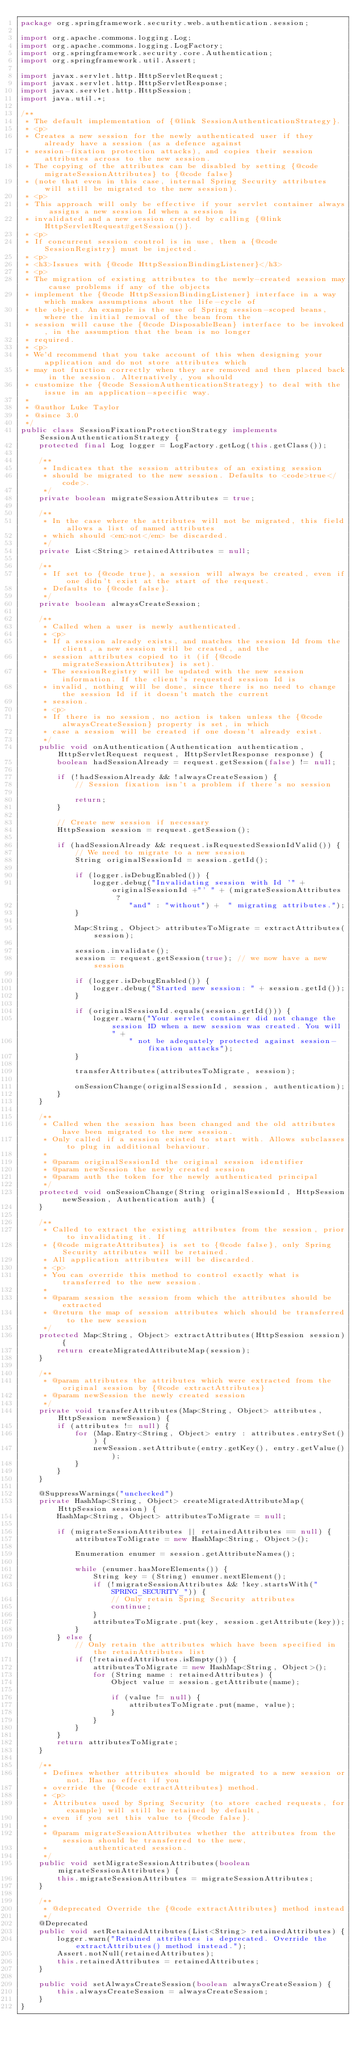Convert code to text. <code><loc_0><loc_0><loc_500><loc_500><_Java_>package org.springframework.security.web.authentication.session;

import org.apache.commons.logging.Log;
import org.apache.commons.logging.LogFactory;
import org.springframework.security.core.Authentication;
import org.springframework.util.Assert;

import javax.servlet.http.HttpServletRequest;
import javax.servlet.http.HttpServletResponse;
import javax.servlet.http.HttpSession;
import java.util.*;

/**
 * The default implementation of {@link SessionAuthenticationStrategy}.
 * <p>
 * Creates a new session for the newly authenticated user if they already have a session (as a defence against
 * session-fixation protection attacks), and copies their session attributes across to the new session.
 * The copying of the attributes can be disabled by setting {@code migrateSessionAttributes} to {@code false}
 * (note that even in this case, internal Spring Security attributes will still be migrated to the new session).
 * <p>
 * This approach will only be effective if your servlet container always assigns a new session Id when a session is
 * invalidated and a new session created by calling {@link HttpServletRequest#getSession()}.
 * <p>
 * If concurrent session control is in use, then a {@code SessionRegistry} must be injected.
 * <p>
 * <h3>Issues with {@code HttpSessionBindingListener}</h3>
 * <p>
 * The migration of existing attributes to the newly-created session may cause problems if any of the objects
 * implement the {@code HttpSessionBindingListener} interface in a way which makes assumptions about the life-cycle of
 * the object. An example is the use of Spring session-scoped beans, where the initial removal of the bean from the
 * session will cause the {@code DisposableBean} interface to be invoked, in the assumption that the bean is no longer
 * required.
 * <p>
 * We'd recommend that you take account of this when designing your application and do not store attributes which
 * may not function correctly when they are removed and then placed back in the session. Alternatively, you should
 * customize the {@code SessionAuthenticationStrategy} to deal with the issue in an application-specific way.
 *
 * @author Luke Taylor
 * @since 3.0
 */
public class SessionFixationProtectionStrategy implements SessionAuthenticationStrategy {
    protected final Log logger = LogFactory.getLog(this.getClass());

    /**
     * Indicates that the session attributes of an existing session
     * should be migrated to the new session. Defaults to <code>true</code>.
     */
    private boolean migrateSessionAttributes = true;

    /**
     * In the case where the attributes will not be migrated, this field allows a list of named attributes
     * which should <em>not</em> be discarded.
     */
    private List<String> retainedAttributes = null;

    /**
     * If set to {@code true}, a session will always be created, even if one didn't exist at the start of the request.
     * Defaults to {@code false}.
     */
    private boolean alwaysCreateSession;

    /**
     * Called when a user is newly authenticated.
     * <p>
     * If a session already exists, and matches the session Id from the client, a new session will be created, and the
     * session attributes copied to it (if {@code migrateSessionAttributes} is set).
     * The sessionRegistry will be updated with the new session information. If the client's requested session Id is
     * invalid, nothing will be done, since there is no need to change the session Id if it doesn't match the current
     * session.
     * <p>
     * If there is no session, no action is taken unless the {@code alwaysCreateSession} property is set, in which
     * case a session will be created if one doesn't already exist.
     */
    public void onAuthentication(Authentication authentication, HttpServletRequest request, HttpServletResponse response) {
        boolean hadSessionAlready = request.getSession(false) != null;

        if (!hadSessionAlready && !alwaysCreateSession) {
            // Session fixation isn't a problem if there's no session

            return;
        }

        // Create new session if necessary
        HttpSession session = request.getSession();

        if (hadSessionAlready && request.isRequestedSessionIdValid()) {
            // We need to migrate to a new session
            String originalSessionId = session.getId();

            if (logger.isDebugEnabled()) {
                logger.debug("Invalidating session with Id '" + originalSessionId +"' " + (migrateSessionAttributes ?
                        "and" : "without") +  " migrating attributes.");
            }

            Map<String, Object> attributesToMigrate = extractAttributes(session);

            session.invalidate();
            session = request.getSession(true); // we now have a new session

            if (logger.isDebugEnabled()) {
                logger.debug("Started new session: " + session.getId());
            }

            if (originalSessionId.equals(session.getId())) {
                logger.warn("Your servlet container did not change the session ID when a new session was created. You will" +
                        " not be adequately protected against session-fixation attacks");
            }

            transferAttributes(attributesToMigrate, session);

            onSessionChange(originalSessionId, session, authentication);
        }
    }

    /**
     * Called when the session has been changed and the old attributes have been migrated to the new session.
     * Only called if a session existed to start with. Allows subclasses to plug in additional behaviour.
     *
     * @param originalSessionId the original session identifier
     * @param newSession the newly created session
     * @param auth the token for the newly authenticated principal
     */
    protected void onSessionChange(String originalSessionId, HttpSession newSession, Authentication auth) {
    }

    /**
     * Called to extract the existing attributes from the session, prior to invalidating it. If
     * {@code migrateAttributes} is set to {@code false}, only Spring Security attributes will be retained.
     * All application attributes will be discarded.
     * <p>
     * You can override this method to control exactly what is transferred to the new session.
     *
     * @param session the session from which the attributes should be extracted
     * @return the map of session attributes which should be transferred to the new session
     */
    protected Map<String, Object> extractAttributes(HttpSession session) {
        return createMigratedAttributeMap(session);
    }

    /**
     * @param attributes the attributes which were extracted from the original session by {@code extractAttributes}
     * @param newSession the newly created session
     */
    private void transferAttributes(Map<String, Object> attributes, HttpSession newSession) {
        if (attributes != null) {
            for (Map.Entry<String, Object> entry : attributes.entrySet()) {
                newSession.setAttribute(entry.getKey(), entry.getValue());
            }
        }
    }

    @SuppressWarnings("unchecked")
    private HashMap<String, Object> createMigratedAttributeMap(HttpSession session) {
        HashMap<String, Object> attributesToMigrate = null;

        if (migrateSessionAttributes || retainedAttributes == null) {
            attributesToMigrate = new HashMap<String, Object>();

            Enumeration enumer = session.getAttributeNames();

            while (enumer.hasMoreElements()) {
                String key = (String) enumer.nextElement();
                if (!migrateSessionAttributes && !key.startsWith("SPRING_SECURITY_")) {
                    // Only retain Spring Security attributes
                    continue;
                }
                attributesToMigrate.put(key, session.getAttribute(key));
            }
        } else {
            // Only retain the attributes which have been specified in the retainAttributes list
            if (!retainedAttributes.isEmpty()) {
                attributesToMigrate = new HashMap<String, Object>();
                for (String name : retainedAttributes) {
                    Object value = session.getAttribute(name);

                    if (value != null) {
                        attributesToMigrate.put(name, value);
                    }
                }
            }
        }
        return attributesToMigrate;
    }

    /**
     * Defines whether attributes should be migrated to a new session or not. Has no effect if you
     * override the {@code extractAttributes} method.
     * <p>
     * Attributes used by Spring Security (to store cached requests, for example) will still be retained by default,
     * even if you set this value to {@code false}.
     *
     * @param migrateSessionAttributes whether the attributes from the session should be transferred to the new,
     *         authenticated session.
     */
    public void setMigrateSessionAttributes(boolean migrateSessionAttributes) {
        this.migrateSessionAttributes = migrateSessionAttributes;
    }

    /**
     * @deprecated Override the {@code extractAttributes} method instead
     */
    @Deprecated
    public void setRetainedAttributes(List<String> retainedAttributes) {
        logger.warn("Retained attributes is deprecated. Override the extractAttributes() method instead.");
        Assert.notNull(retainedAttributes);
        this.retainedAttributes = retainedAttributes;
    }

    public void setAlwaysCreateSession(boolean alwaysCreateSession) {
        this.alwaysCreateSession = alwaysCreateSession;
    }
}
</code> 